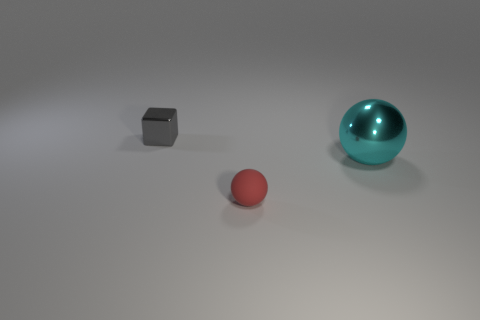Add 3 tiny red matte objects. How many objects exist? 6 Subtract all cubes. How many objects are left? 2 Subtract all tiny gray metal blocks. Subtract all large cyan things. How many objects are left? 1 Add 1 cyan spheres. How many cyan spheres are left? 2 Add 1 gray shiny objects. How many gray shiny objects exist? 2 Subtract 0 red cylinders. How many objects are left? 3 